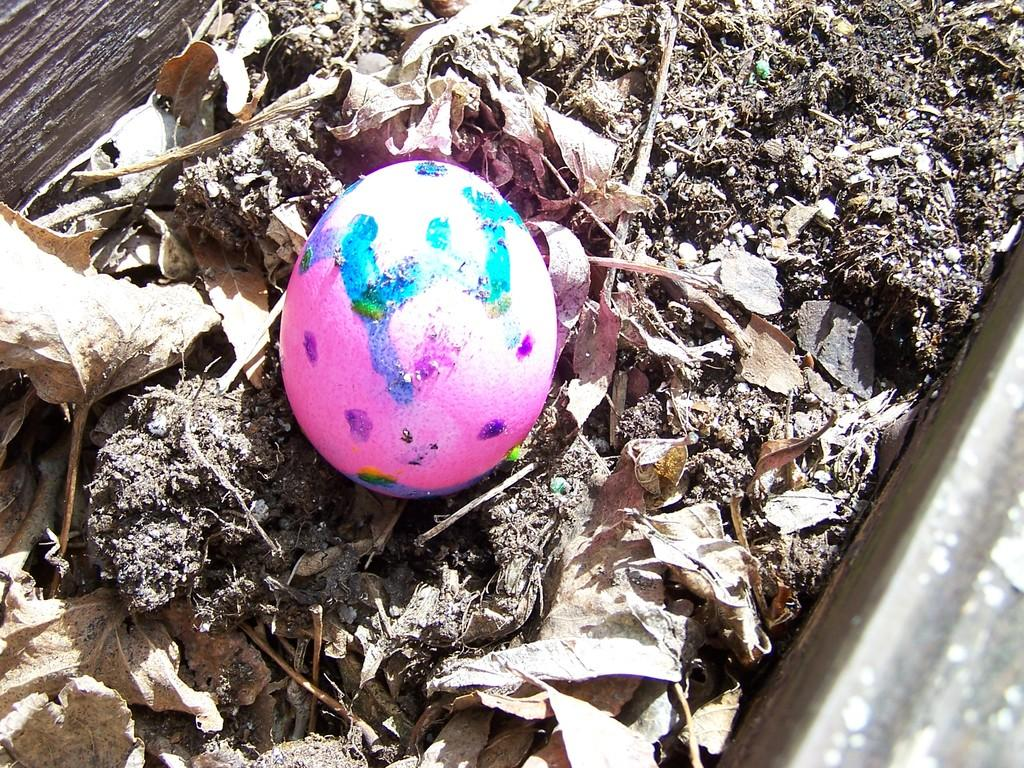What is the main substance present in the picture? There is mud in the picture. What objects can be found within the mud? There are twigs, dried leaves, and an egg in the mud. Can you describe the egg in the picture? The egg is painted with pink color and has designs on it. What type of event is taking place with the sheep in the picture? There are no sheep present in the image, so it is not possible to discuss any events involving them. 